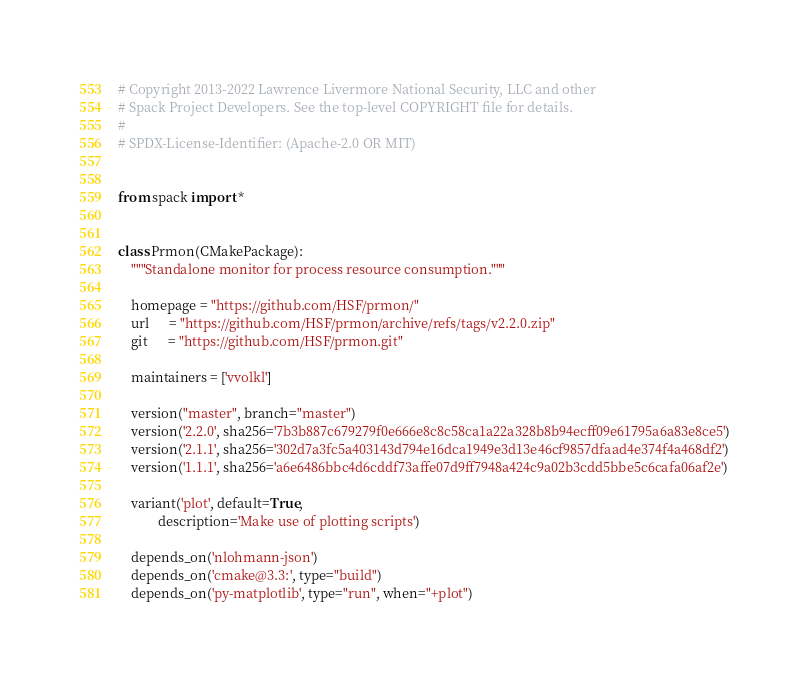Convert code to text. <code><loc_0><loc_0><loc_500><loc_500><_Python_># Copyright 2013-2022 Lawrence Livermore National Security, LLC and other
# Spack Project Developers. See the top-level COPYRIGHT file for details.
#
# SPDX-License-Identifier: (Apache-2.0 OR MIT)


from spack import *


class Prmon(CMakePackage):
    """Standalone monitor for process resource consumption."""

    homepage = "https://github.com/HSF/prmon/"
    url      = "https://github.com/HSF/prmon/archive/refs/tags/v2.2.0.zip"
    git      = "https://github.com/HSF/prmon.git"

    maintainers = ['vvolkl']

    version("master", branch="master")
    version('2.2.0', sha256='7b3b887c679279f0e666e8c8c58ca1a22a328b8b94ecff09e61795a6a83e8ce5')
    version('2.1.1', sha256='302d7a3fc5a403143d794e16dca1949e3d13e46cf9857dfaad4e374f4a468df2')
    version('1.1.1', sha256='a6e6486bbc4d6cddf73affe07d9ff7948a424c9a02b3cdd5bbe5c6cafa06af2e')

    variant('plot', default=True,
            description='Make use of plotting scripts')

    depends_on('nlohmann-json')
    depends_on('cmake@3.3:', type="build")
    depends_on('py-matplotlib', type="run", when="+plot")
</code> 